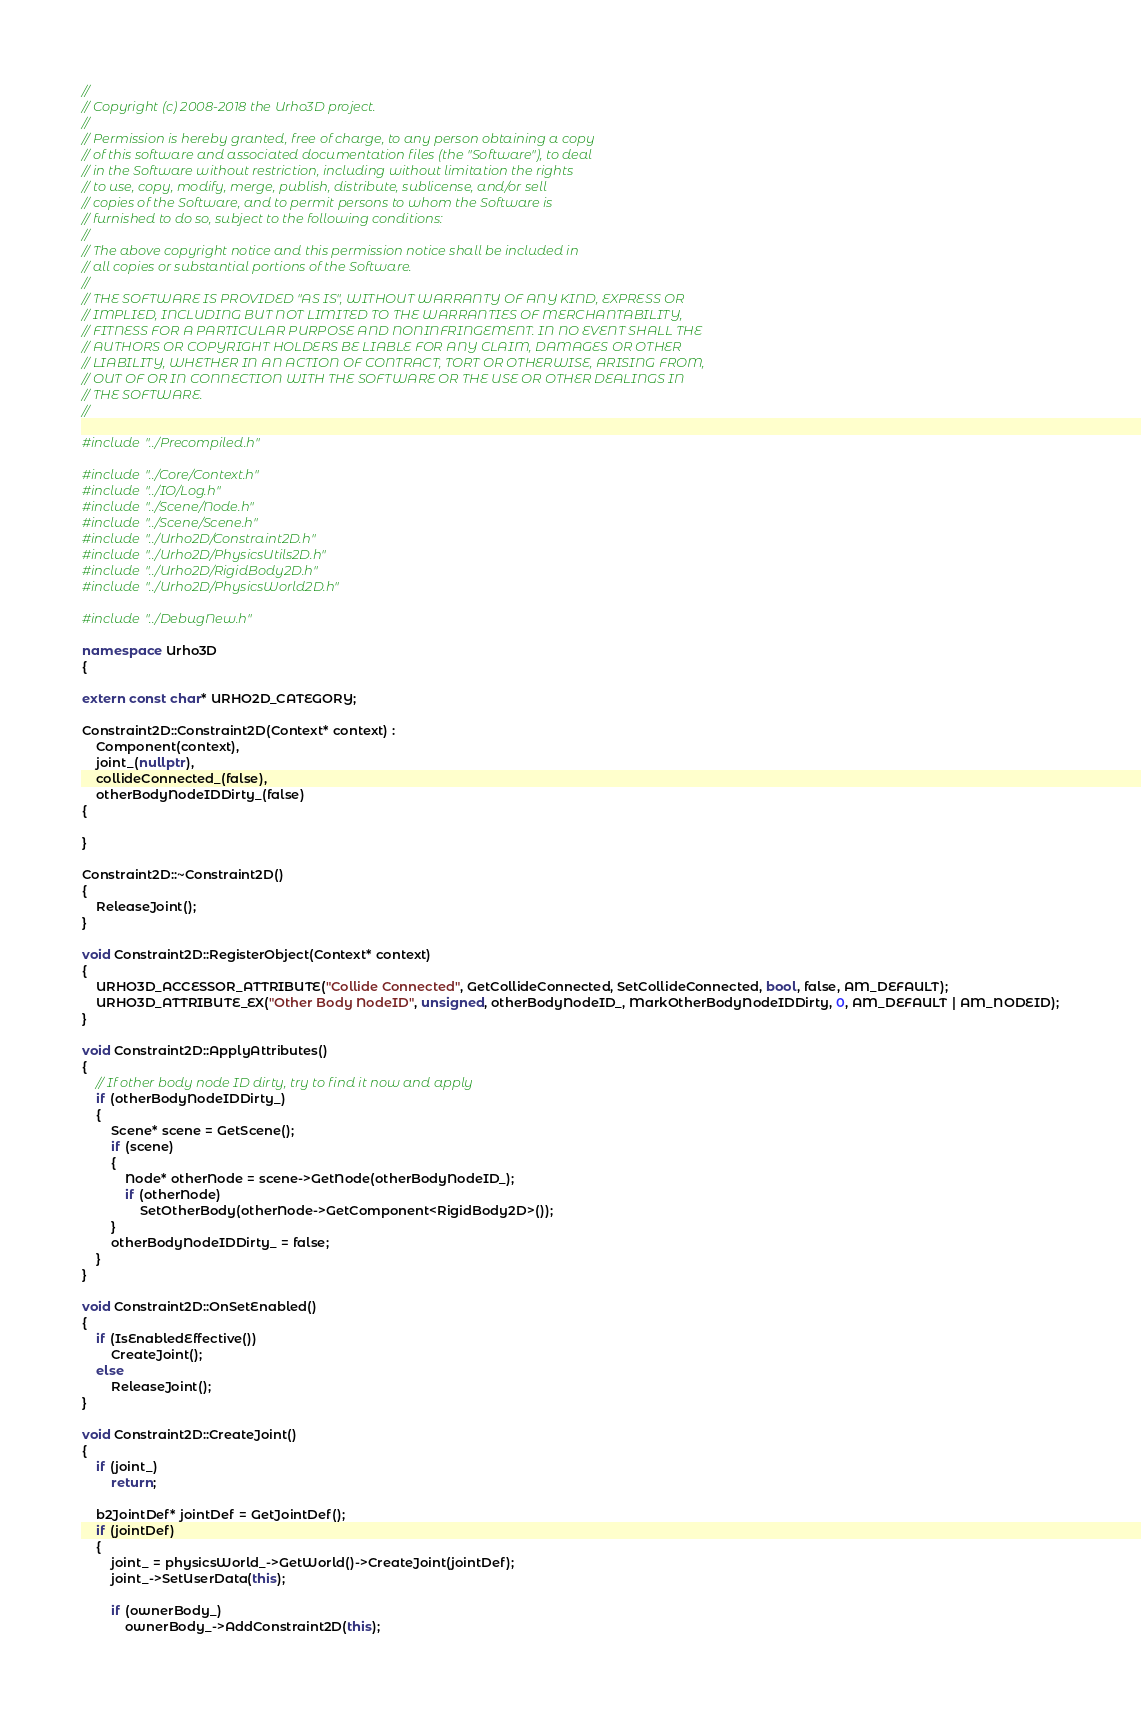<code> <loc_0><loc_0><loc_500><loc_500><_C++_>//
// Copyright (c) 2008-2018 the Urho3D project.
//
// Permission is hereby granted, free of charge, to any person obtaining a copy
// of this software and associated documentation files (the "Software"), to deal
// in the Software without restriction, including without limitation the rights
// to use, copy, modify, merge, publish, distribute, sublicense, and/or sell
// copies of the Software, and to permit persons to whom the Software is
// furnished to do so, subject to the following conditions:
//
// The above copyright notice and this permission notice shall be included in
// all copies or substantial portions of the Software.
//
// THE SOFTWARE IS PROVIDED "AS IS", WITHOUT WARRANTY OF ANY KIND, EXPRESS OR
// IMPLIED, INCLUDING BUT NOT LIMITED TO THE WARRANTIES OF MERCHANTABILITY,
// FITNESS FOR A PARTICULAR PURPOSE AND NONINFRINGEMENT. IN NO EVENT SHALL THE
// AUTHORS OR COPYRIGHT HOLDERS BE LIABLE FOR ANY CLAIM, DAMAGES OR OTHER
// LIABILITY, WHETHER IN AN ACTION OF CONTRACT, TORT OR OTHERWISE, ARISING FROM,
// OUT OF OR IN CONNECTION WITH THE SOFTWARE OR THE USE OR OTHER DEALINGS IN
// THE SOFTWARE.
//

#include "../Precompiled.h"

#include "../Core/Context.h"
#include "../IO/Log.h"
#include "../Scene/Node.h"
#include "../Scene/Scene.h"
#include "../Urho2D/Constraint2D.h"
#include "../Urho2D/PhysicsUtils2D.h"
#include "../Urho2D/RigidBody2D.h"
#include "../Urho2D/PhysicsWorld2D.h"

#include "../DebugNew.h"

namespace Urho3D
{

extern const char* URHO2D_CATEGORY;

Constraint2D::Constraint2D(Context* context) :
    Component(context),
    joint_(nullptr),
    collideConnected_(false),
    otherBodyNodeIDDirty_(false)
{

}

Constraint2D::~Constraint2D()
{
    ReleaseJoint();
}

void Constraint2D::RegisterObject(Context* context)
{
    URHO3D_ACCESSOR_ATTRIBUTE("Collide Connected", GetCollideConnected, SetCollideConnected, bool, false, AM_DEFAULT);
    URHO3D_ATTRIBUTE_EX("Other Body NodeID", unsigned, otherBodyNodeID_, MarkOtherBodyNodeIDDirty, 0, AM_DEFAULT | AM_NODEID);
}

void Constraint2D::ApplyAttributes()
{
    // If other body node ID dirty, try to find it now and apply
    if (otherBodyNodeIDDirty_)
    {
        Scene* scene = GetScene();
        if (scene)
        {
            Node* otherNode = scene->GetNode(otherBodyNodeID_);
            if (otherNode)
                SetOtherBody(otherNode->GetComponent<RigidBody2D>());
        }
        otherBodyNodeIDDirty_ = false;
    }
}

void Constraint2D::OnSetEnabled()
{
    if (IsEnabledEffective())
        CreateJoint();
    else
        ReleaseJoint();
}

void Constraint2D::CreateJoint()
{
    if (joint_)
        return;

    b2JointDef* jointDef = GetJointDef();
    if (jointDef)
    {
        joint_ = physicsWorld_->GetWorld()->CreateJoint(jointDef);
        joint_->SetUserData(this);

        if (ownerBody_)
            ownerBody_->AddConstraint2D(this);
</code> 